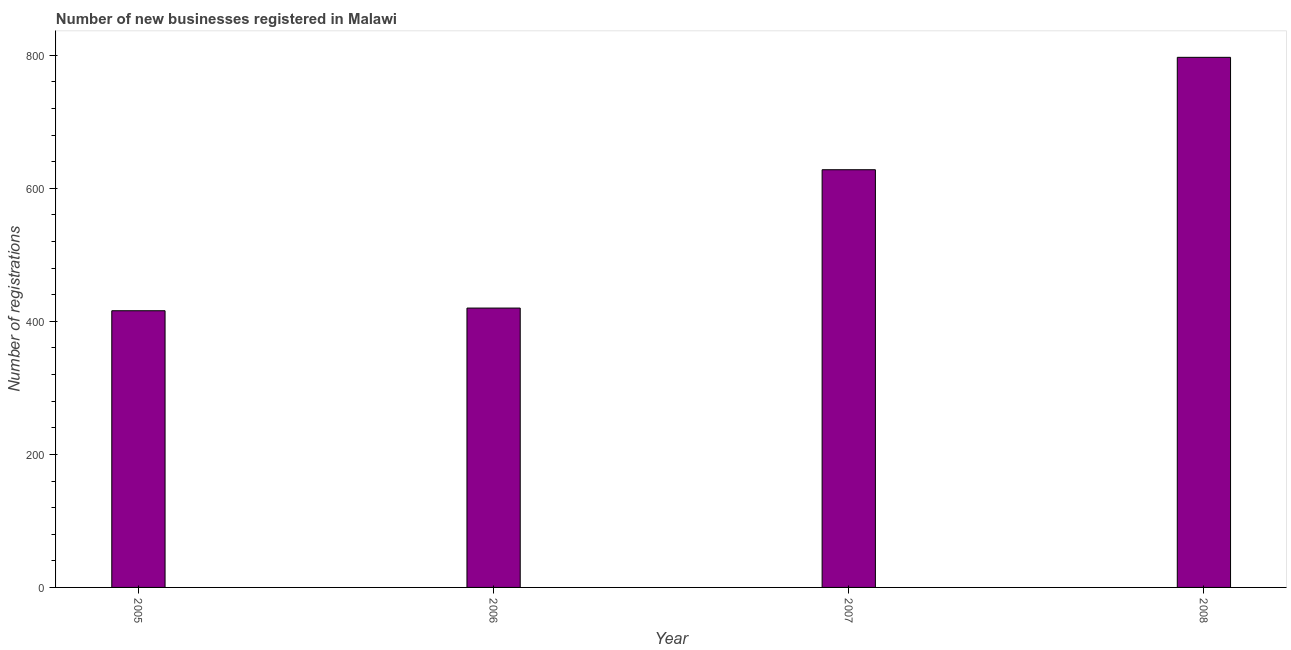Does the graph contain grids?
Make the answer very short. No. What is the title of the graph?
Offer a very short reply. Number of new businesses registered in Malawi. What is the label or title of the X-axis?
Your response must be concise. Year. What is the label or title of the Y-axis?
Your answer should be very brief. Number of registrations. What is the number of new business registrations in 2005?
Offer a terse response. 416. Across all years, what is the maximum number of new business registrations?
Provide a succinct answer. 797. Across all years, what is the minimum number of new business registrations?
Make the answer very short. 416. In which year was the number of new business registrations maximum?
Your answer should be very brief. 2008. What is the sum of the number of new business registrations?
Provide a short and direct response. 2261. What is the difference between the number of new business registrations in 2005 and 2008?
Provide a succinct answer. -381. What is the average number of new business registrations per year?
Offer a terse response. 565. What is the median number of new business registrations?
Offer a terse response. 524. Do a majority of the years between 2006 and 2005 (inclusive) have number of new business registrations greater than 160 ?
Your response must be concise. No. What is the ratio of the number of new business registrations in 2007 to that in 2008?
Offer a very short reply. 0.79. Is the number of new business registrations in 2005 less than that in 2006?
Ensure brevity in your answer.  Yes. Is the difference between the number of new business registrations in 2006 and 2008 greater than the difference between any two years?
Ensure brevity in your answer.  No. What is the difference between the highest and the second highest number of new business registrations?
Offer a terse response. 169. Is the sum of the number of new business registrations in 2006 and 2008 greater than the maximum number of new business registrations across all years?
Ensure brevity in your answer.  Yes. What is the difference between the highest and the lowest number of new business registrations?
Give a very brief answer. 381. How many bars are there?
Provide a short and direct response. 4. What is the difference between two consecutive major ticks on the Y-axis?
Offer a terse response. 200. Are the values on the major ticks of Y-axis written in scientific E-notation?
Provide a succinct answer. No. What is the Number of registrations in 2005?
Offer a very short reply. 416. What is the Number of registrations of 2006?
Your answer should be very brief. 420. What is the Number of registrations in 2007?
Provide a succinct answer. 628. What is the Number of registrations of 2008?
Your response must be concise. 797. What is the difference between the Number of registrations in 2005 and 2007?
Ensure brevity in your answer.  -212. What is the difference between the Number of registrations in 2005 and 2008?
Offer a very short reply. -381. What is the difference between the Number of registrations in 2006 and 2007?
Provide a short and direct response. -208. What is the difference between the Number of registrations in 2006 and 2008?
Ensure brevity in your answer.  -377. What is the difference between the Number of registrations in 2007 and 2008?
Your answer should be compact. -169. What is the ratio of the Number of registrations in 2005 to that in 2007?
Your answer should be compact. 0.66. What is the ratio of the Number of registrations in 2005 to that in 2008?
Provide a succinct answer. 0.52. What is the ratio of the Number of registrations in 2006 to that in 2007?
Your answer should be compact. 0.67. What is the ratio of the Number of registrations in 2006 to that in 2008?
Give a very brief answer. 0.53. What is the ratio of the Number of registrations in 2007 to that in 2008?
Provide a short and direct response. 0.79. 